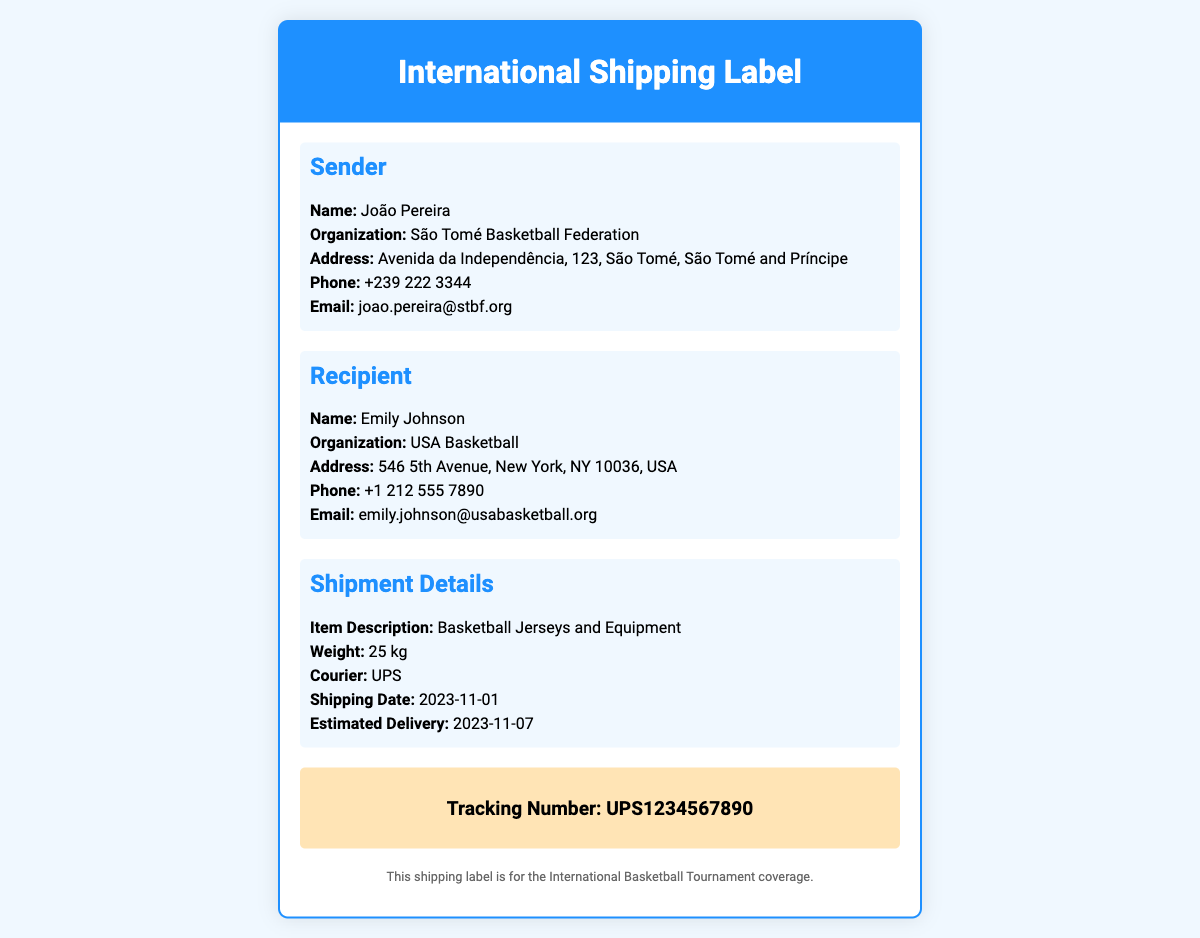what is the sender's name? The sender's name is provided in the document under the Sender section.
Answer: João Pereira what is the recipient's organization? The document specifies the recipient's organization in the Recipient section.
Answer: USA Basketball what is the weight of the shipment? The shipment weight is mentioned in the Shipment Details section of the document.
Answer: 25 kg what is the shipping date? The shipping date is listed in the Shipment Details section for reference.
Answer: 2023-11-01 who is the courier for the shipment? The document indicates which courier is handling the shipment in the Shipment Details.
Answer: UPS what is the email of the sender? The sender's email address can be found in the Sender section.
Answer: joao.pereira@stbf.org when is the estimated delivery date? The estimated delivery date is included in the Shipment Details section.
Answer: 2023-11-07 what is the purpose of this shipping label? The document notes the purpose of the label in the footer section.
Answer: International Basketball Tournament coverage what is the tracking number? The tracking number is highlighted in the tracking section of the document.
Answer: UPS1234567890 what is the address of the recipient? The recipient's full address is detailed in the Recipient section of the document.
Answer: 546 5th Avenue, New York, NY 10036, USA 